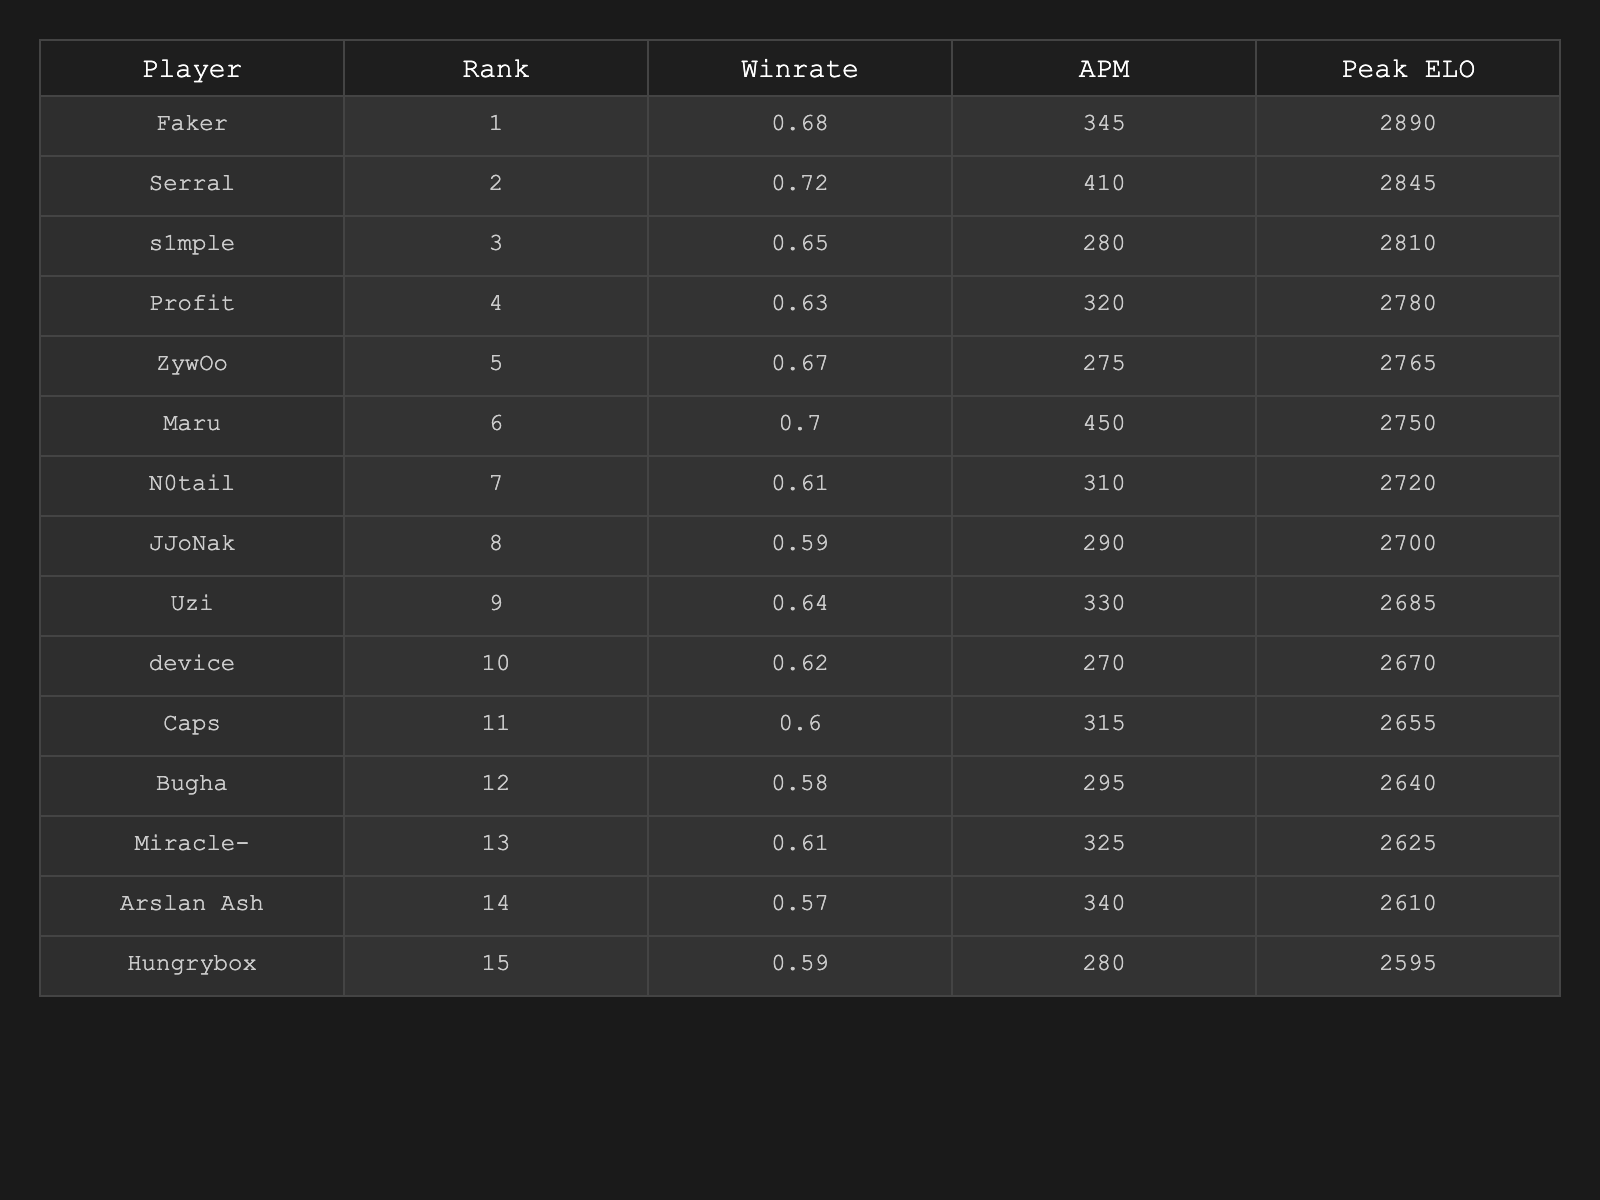What is the win rate of Maru? The win rate of Maru can be found directly in the table; it is listed as 0.70.
Answer: 0.70 Who has the highest Peak ELO? By checking the table, Serral has the highest Peak ELO, which is 2845.
Answer: 2845 What is the average APM of the top 5 players? The APMs of the top 5 players are 345, 410, 280, 275, and 450. Adding them gives 1860. Dividing by 5 results in an average of 372.
Answer: 372 Is the win rate of Uzi greater than that of JJoNak? Uzi has a win rate of 0.64 and JJoNak has 0.59. Since 0.64 is greater than 0.59, the statement is true.
Answer: Yes What is the difference in Peak ELO between the highest and the lowest-ranked player? The highest-ranked player is Faker with a Peak ELO of 2890, and the lowest is Hungrybox with 2595. The difference is 2890 - 2595 = 295.
Answer: 295 Which player has the lowest win rate among the top 15? Looking at the win rates in the table, Arslan Ash has the lowest win rate at 0.57.
Answer: 0.57 What percentage of players have a win rate above 0.65? The players with win rates above 0.65 are Serral (0.72), Maru (0.70), and Faker (0.68), totaling 3. There are 15 players in total, so the percentage is (3/15) * 100 = 20%.
Answer: 20% What is the combined APM of the top 10 players? The APMs of the top 10 players are 345, 410, 280, 320, 275, 450, 310, 290, 330, and 270. Adding them yields 2780.
Answer: 2780 Does the top-ranked player have a win rate lower than 0.70? Faker, the top-ranked player, has a win rate of 0.68, which is indeed lower than 0.70. Therefore, the statement is true.
Answer: Yes What is the average Peak ELO of players ranked 1 to 5? The Peak ELOs of players ranked 1 to 5 are 2890, 2845, 2810, 2780, and 2765. Summing these gives 14090. Dividing by 5 results in an average of 2818.
Answer: 2818 